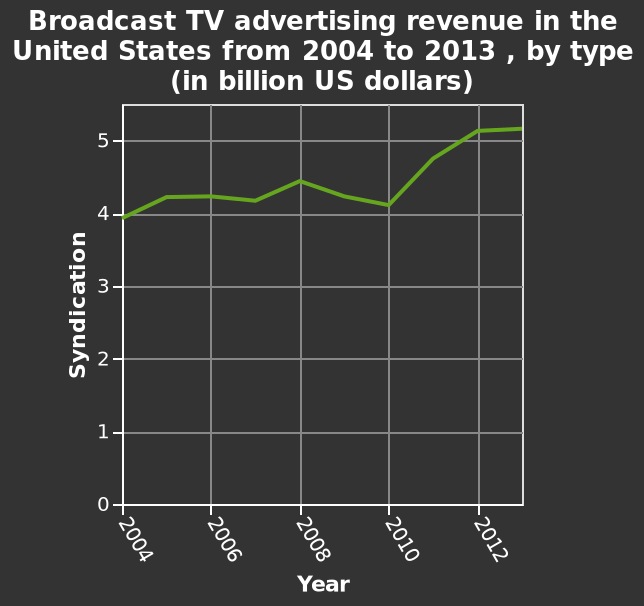<image>
please summary the statistics and relations of the chart Broadcast TV revenue has been consistently above 4billion since 2004, trending upwards slightly in 2008 before dropping back down to almost 2004 levels in 2010, since 2010 there has been an upward trend of revenue reaching 5billion and staying that way for the next couple of years that have been charted. Offer a thorough analysis of the image. Syndication rose from $4bn in 2004 to $5.2bn in 2012, with a sharp increase from just above $4bn in 2010 to just above $5bn at the start of 2012. 